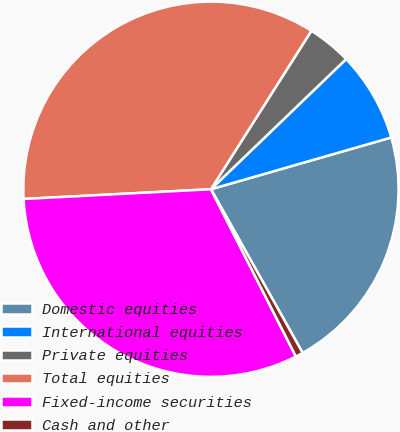<chart> <loc_0><loc_0><loc_500><loc_500><pie_chart><fcel>Domestic equities<fcel>International equities<fcel>Private equities<fcel>Total equities<fcel>Fixed-income securities<fcel>Cash and other<nl><fcel>21.32%<fcel>7.75%<fcel>3.81%<fcel>34.82%<fcel>31.65%<fcel>0.65%<nl></chart> 